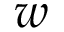<formula> <loc_0><loc_0><loc_500><loc_500>w</formula> 